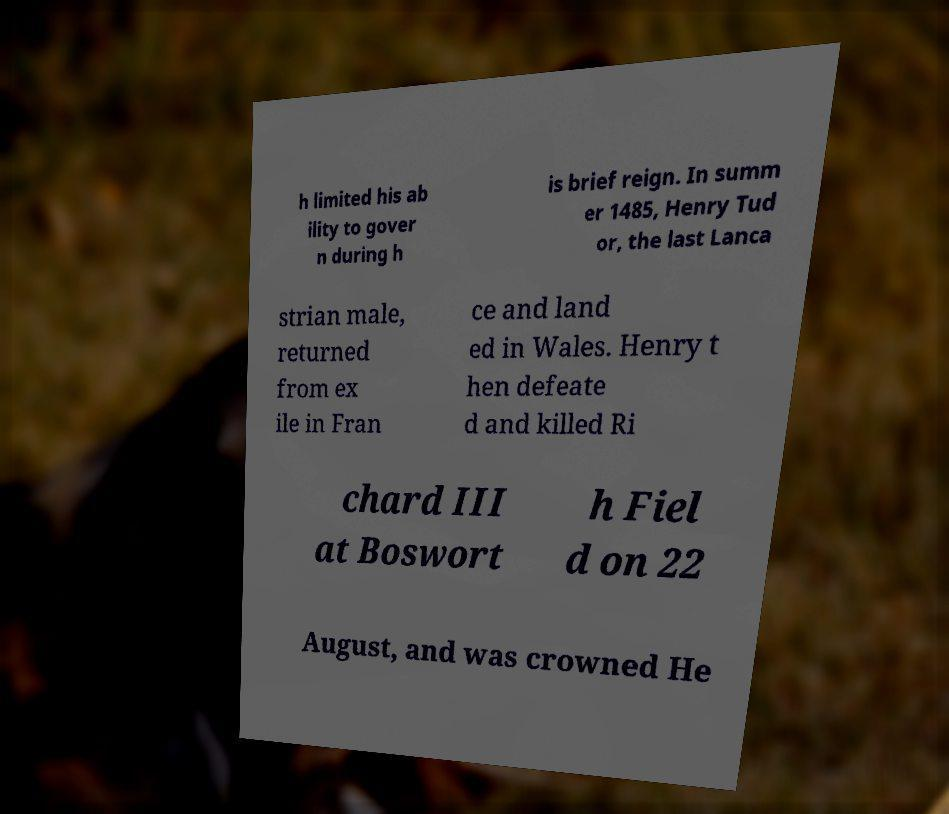I need the written content from this picture converted into text. Can you do that? h limited his ab ility to gover n during h is brief reign. In summ er 1485, Henry Tud or, the last Lanca strian male, returned from ex ile in Fran ce and land ed in Wales. Henry t hen defeate d and killed Ri chard III at Boswort h Fiel d on 22 August, and was crowned He 